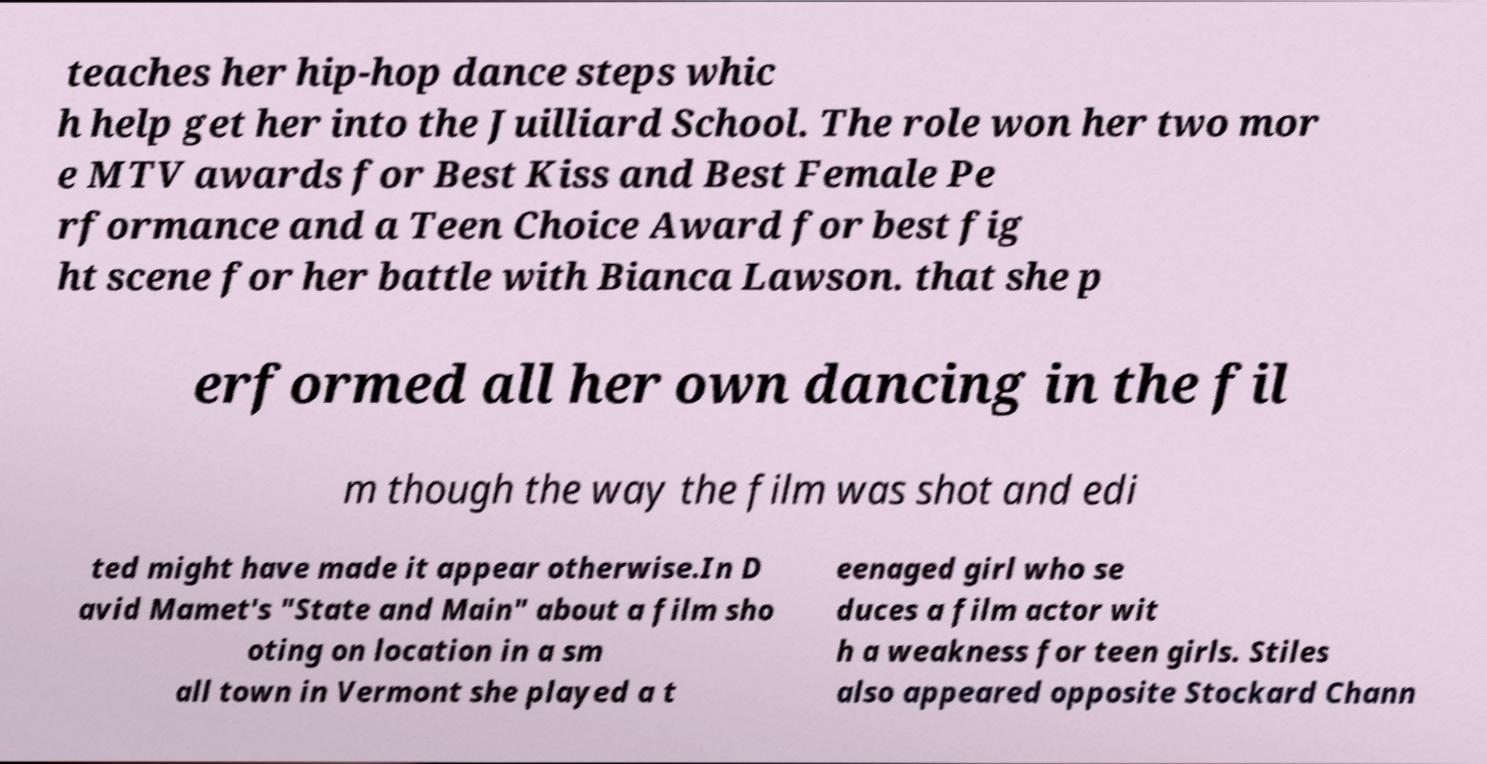Please identify and transcribe the text found in this image. teaches her hip-hop dance steps whic h help get her into the Juilliard School. The role won her two mor e MTV awards for Best Kiss and Best Female Pe rformance and a Teen Choice Award for best fig ht scene for her battle with Bianca Lawson. that she p erformed all her own dancing in the fil m though the way the film was shot and edi ted might have made it appear otherwise.In D avid Mamet's "State and Main" about a film sho oting on location in a sm all town in Vermont she played a t eenaged girl who se duces a film actor wit h a weakness for teen girls. Stiles also appeared opposite Stockard Chann 